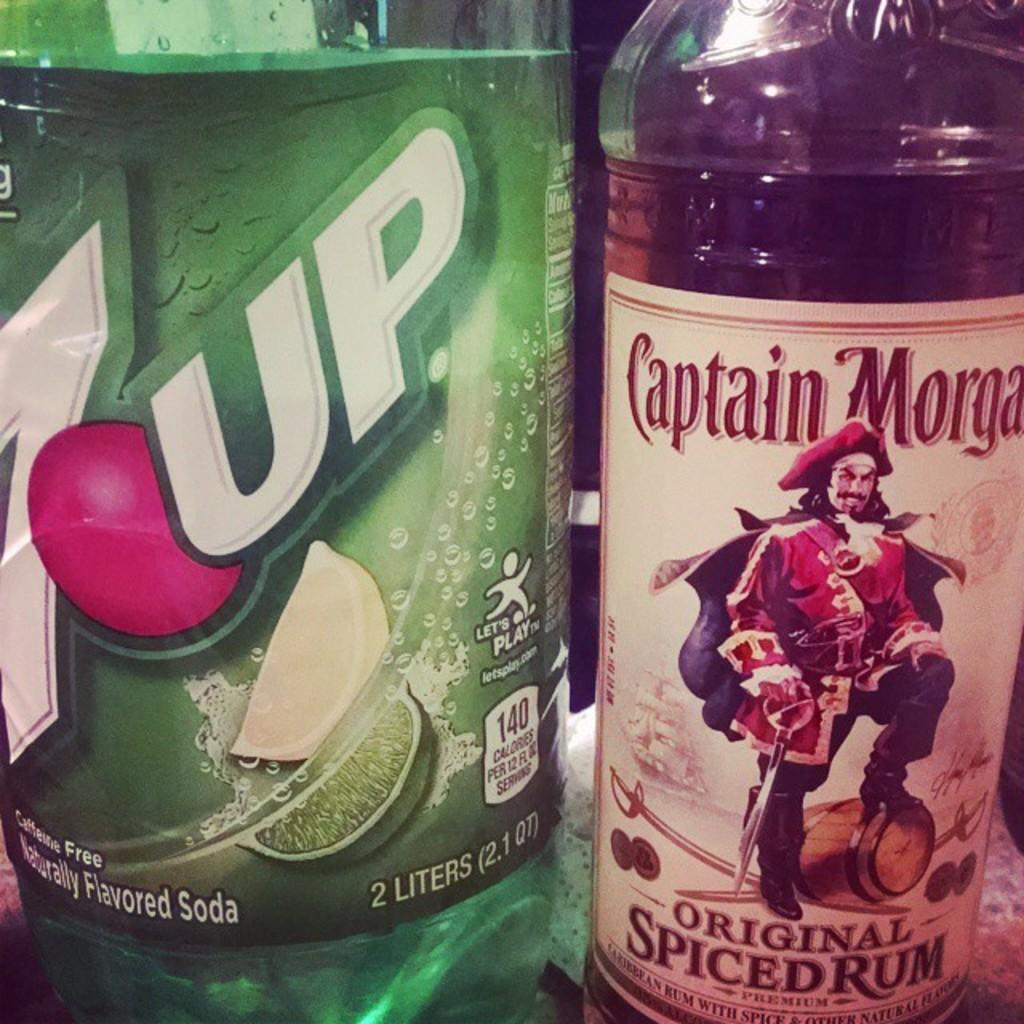How many bottles are visible in the image? There are two bottles in the image. What feature do the bottles have in common? The bottles have labels. What information can be found on the labels? The labels contain text. What type of chain can be seen connecting the two bottles in the image? There is no chain connecting the two bottles in the image. 